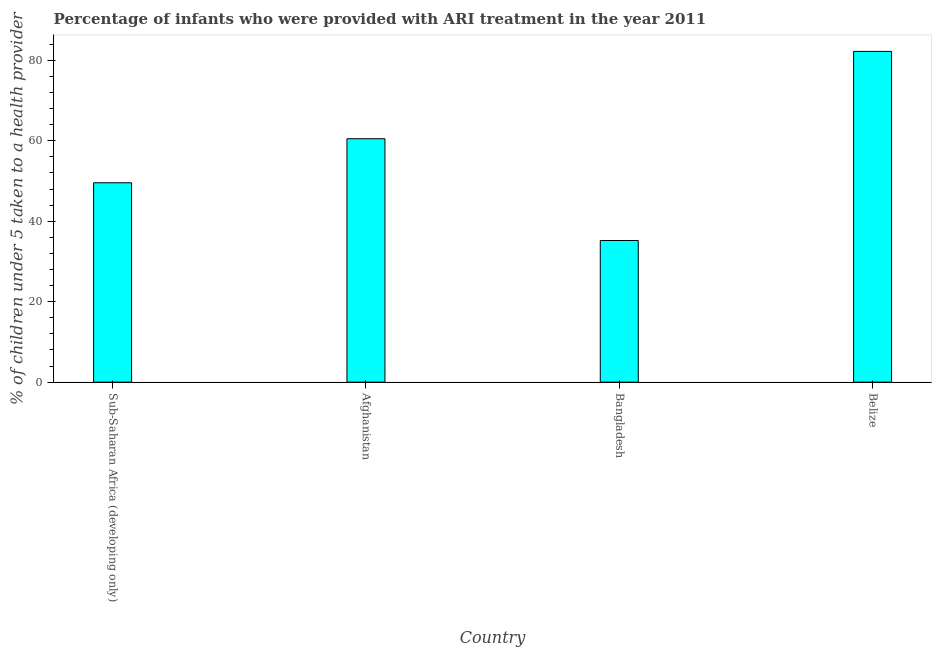Does the graph contain grids?
Offer a very short reply. No. What is the title of the graph?
Provide a short and direct response. Percentage of infants who were provided with ARI treatment in the year 2011. What is the label or title of the Y-axis?
Your answer should be very brief. % of children under 5 taken to a health provider. What is the percentage of children who were provided with ari treatment in Belize?
Provide a succinct answer. 82.2. Across all countries, what is the maximum percentage of children who were provided with ari treatment?
Ensure brevity in your answer.  82.2. Across all countries, what is the minimum percentage of children who were provided with ari treatment?
Keep it short and to the point. 35.2. In which country was the percentage of children who were provided with ari treatment maximum?
Offer a very short reply. Belize. In which country was the percentage of children who were provided with ari treatment minimum?
Provide a succinct answer. Bangladesh. What is the sum of the percentage of children who were provided with ari treatment?
Offer a very short reply. 227.45. What is the difference between the percentage of children who were provided with ari treatment in Bangladesh and Sub-Saharan Africa (developing only)?
Make the answer very short. -14.35. What is the average percentage of children who were provided with ari treatment per country?
Your answer should be compact. 56.86. What is the median percentage of children who were provided with ari treatment?
Offer a very short reply. 55.03. What is the ratio of the percentage of children who were provided with ari treatment in Bangladesh to that in Sub-Saharan Africa (developing only)?
Keep it short and to the point. 0.71. Is the percentage of children who were provided with ari treatment in Belize less than that in Sub-Saharan Africa (developing only)?
Ensure brevity in your answer.  No. What is the difference between the highest and the second highest percentage of children who were provided with ari treatment?
Offer a very short reply. 21.7. How many bars are there?
Your answer should be compact. 4. Are all the bars in the graph horizontal?
Your answer should be very brief. No. What is the % of children under 5 taken to a health provider of Sub-Saharan Africa (developing only)?
Provide a succinct answer. 49.55. What is the % of children under 5 taken to a health provider in Afghanistan?
Offer a terse response. 60.5. What is the % of children under 5 taken to a health provider in Bangladesh?
Your answer should be compact. 35.2. What is the % of children under 5 taken to a health provider in Belize?
Make the answer very short. 82.2. What is the difference between the % of children under 5 taken to a health provider in Sub-Saharan Africa (developing only) and Afghanistan?
Your answer should be compact. -10.95. What is the difference between the % of children under 5 taken to a health provider in Sub-Saharan Africa (developing only) and Bangladesh?
Offer a terse response. 14.35. What is the difference between the % of children under 5 taken to a health provider in Sub-Saharan Africa (developing only) and Belize?
Provide a succinct answer. -32.65. What is the difference between the % of children under 5 taken to a health provider in Afghanistan and Bangladesh?
Your answer should be very brief. 25.3. What is the difference between the % of children under 5 taken to a health provider in Afghanistan and Belize?
Offer a terse response. -21.7. What is the difference between the % of children under 5 taken to a health provider in Bangladesh and Belize?
Give a very brief answer. -47. What is the ratio of the % of children under 5 taken to a health provider in Sub-Saharan Africa (developing only) to that in Afghanistan?
Offer a very short reply. 0.82. What is the ratio of the % of children under 5 taken to a health provider in Sub-Saharan Africa (developing only) to that in Bangladesh?
Offer a very short reply. 1.41. What is the ratio of the % of children under 5 taken to a health provider in Sub-Saharan Africa (developing only) to that in Belize?
Provide a succinct answer. 0.6. What is the ratio of the % of children under 5 taken to a health provider in Afghanistan to that in Bangladesh?
Offer a very short reply. 1.72. What is the ratio of the % of children under 5 taken to a health provider in Afghanistan to that in Belize?
Offer a very short reply. 0.74. What is the ratio of the % of children under 5 taken to a health provider in Bangladesh to that in Belize?
Provide a succinct answer. 0.43. 